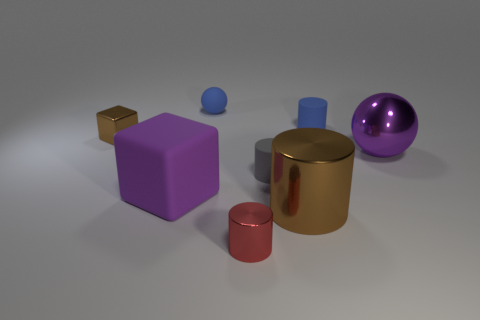There is a shiny sphere; is its color the same as the block that is in front of the purple sphere?
Offer a very short reply. Yes. How many tiny rubber things have the same color as the tiny rubber sphere?
Give a very brief answer. 1. There is a sphere to the right of the blue matte thing that is left of the tiny red shiny cylinder; how many small metal blocks are in front of it?
Your response must be concise. 0. There is a small cylinder that is the same color as the matte ball; what material is it?
Offer a terse response. Rubber. What number of things are either purple objects that are to the right of the tiny blue rubber cylinder or brown things?
Your answer should be compact. 3. There is a matte cylinder that is to the right of the gray thing; does it have the same color as the rubber ball?
Your answer should be compact. Yes. What is the shape of the large metallic thing to the left of the small cylinder that is behind the small brown object?
Offer a terse response. Cylinder. Are there fewer tiny metal cylinders that are on the right side of the tiny brown metallic object than rubber objects that are to the left of the small shiny cylinder?
Your answer should be compact. Yes. What size is the blue thing that is the same shape as the red metallic object?
Provide a succinct answer. Small. What number of things are either blue rubber things on the left side of the small shiny cylinder or things that are behind the red cylinder?
Give a very brief answer. 7. 